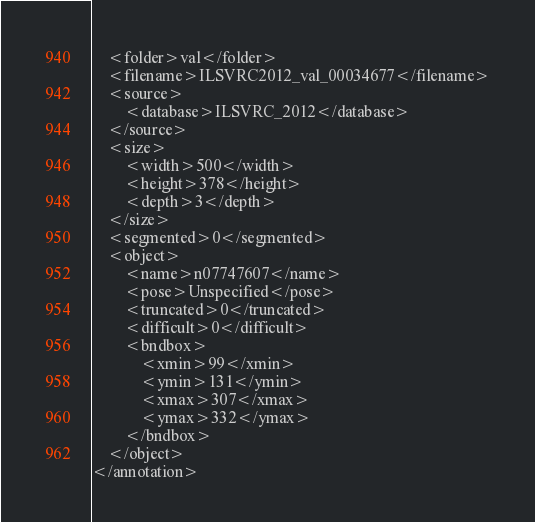Convert code to text. <code><loc_0><loc_0><loc_500><loc_500><_XML_>	<folder>val</folder>
	<filename>ILSVRC2012_val_00034677</filename>
	<source>
		<database>ILSVRC_2012</database>
	</source>
	<size>
		<width>500</width>
		<height>378</height>
		<depth>3</depth>
	</size>
	<segmented>0</segmented>
	<object>
		<name>n07747607</name>
		<pose>Unspecified</pose>
		<truncated>0</truncated>
		<difficult>0</difficult>
		<bndbox>
			<xmin>99</xmin>
			<ymin>131</ymin>
			<xmax>307</xmax>
			<ymax>332</ymax>
		</bndbox>
	</object>
</annotation></code> 